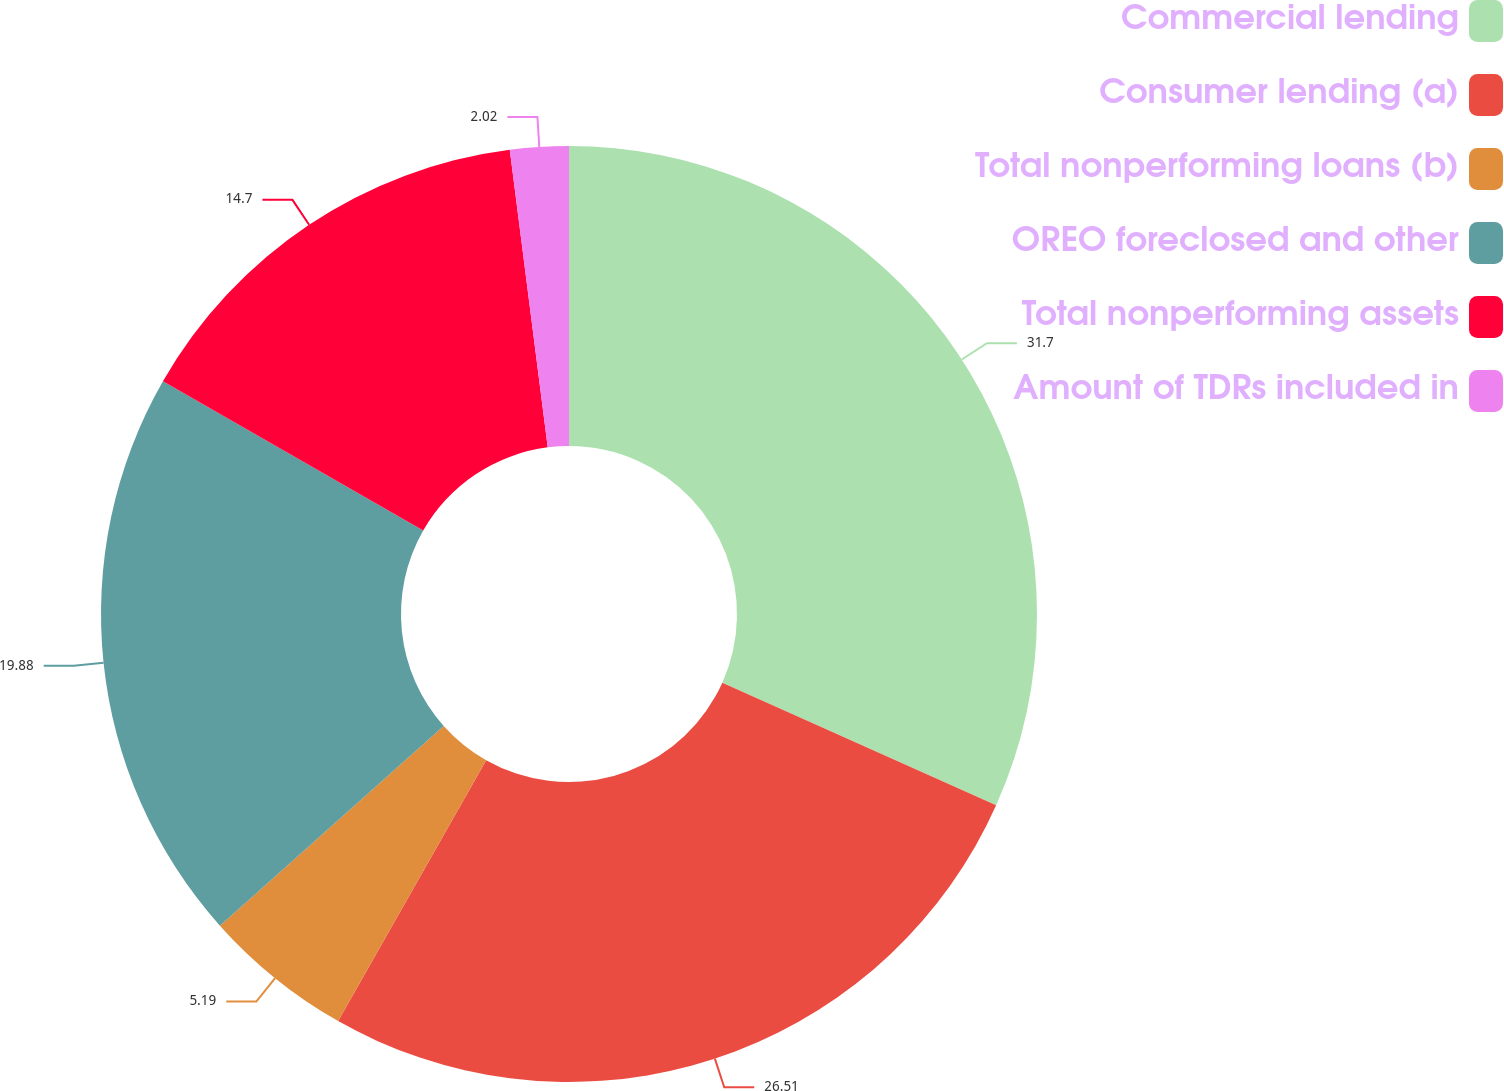<chart> <loc_0><loc_0><loc_500><loc_500><pie_chart><fcel>Commercial lending<fcel>Consumer lending (a)<fcel>Total nonperforming loans (b)<fcel>OREO foreclosed and other<fcel>Total nonperforming assets<fcel>Amount of TDRs included in<nl><fcel>31.7%<fcel>26.51%<fcel>5.19%<fcel>19.88%<fcel>14.7%<fcel>2.02%<nl></chart> 